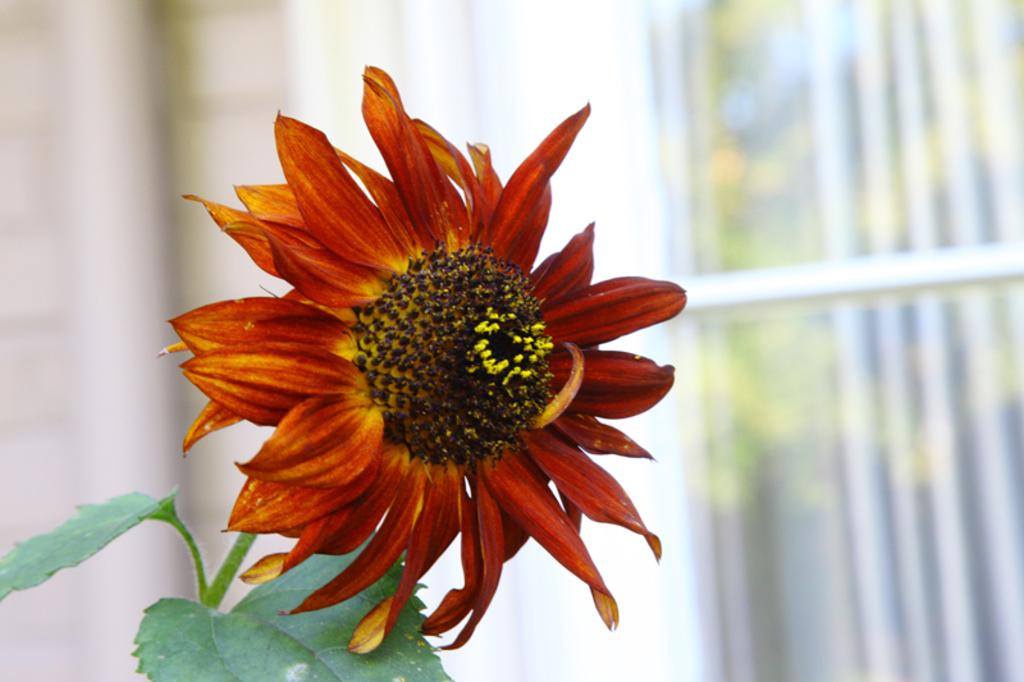What is the main subject of the image? The main subject of the image is a flower. Can you describe the color combination of the flower? The flower has a red and yellow color combination. What else can be seen in the image besides the flower? The flower has green leaves. How would you describe the background of the image? The background of the image is blurred. What type of wire can be seen connecting the flower to the activity in the image? There is no wire or activity present in the image; it only features a flower with green leaves and a blurred background. 